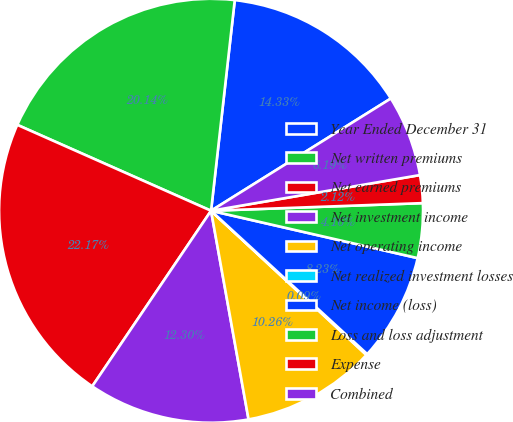Convert chart. <chart><loc_0><loc_0><loc_500><loc_500><pie_chart><fcel>Year Ended December 31<fcel>Net written premiums<fcel>Net earned premiums<fcel>Net investment income<fcel>Net operating income<fcel>Net realized investment losses<fcel>Net income (loss)<fcel>Loss and loss adjustment<fcel>Expense<fcel>Combined<nl><fcel>14.33%<fcel>20.14%<fcel>22.17%<fcel>12.3%<fcel>10.26%<fcel>0.09%<fcel>8.23%<fcel>4.16%<fcel>2.12%<fcel>6.19%<nl></chart> 